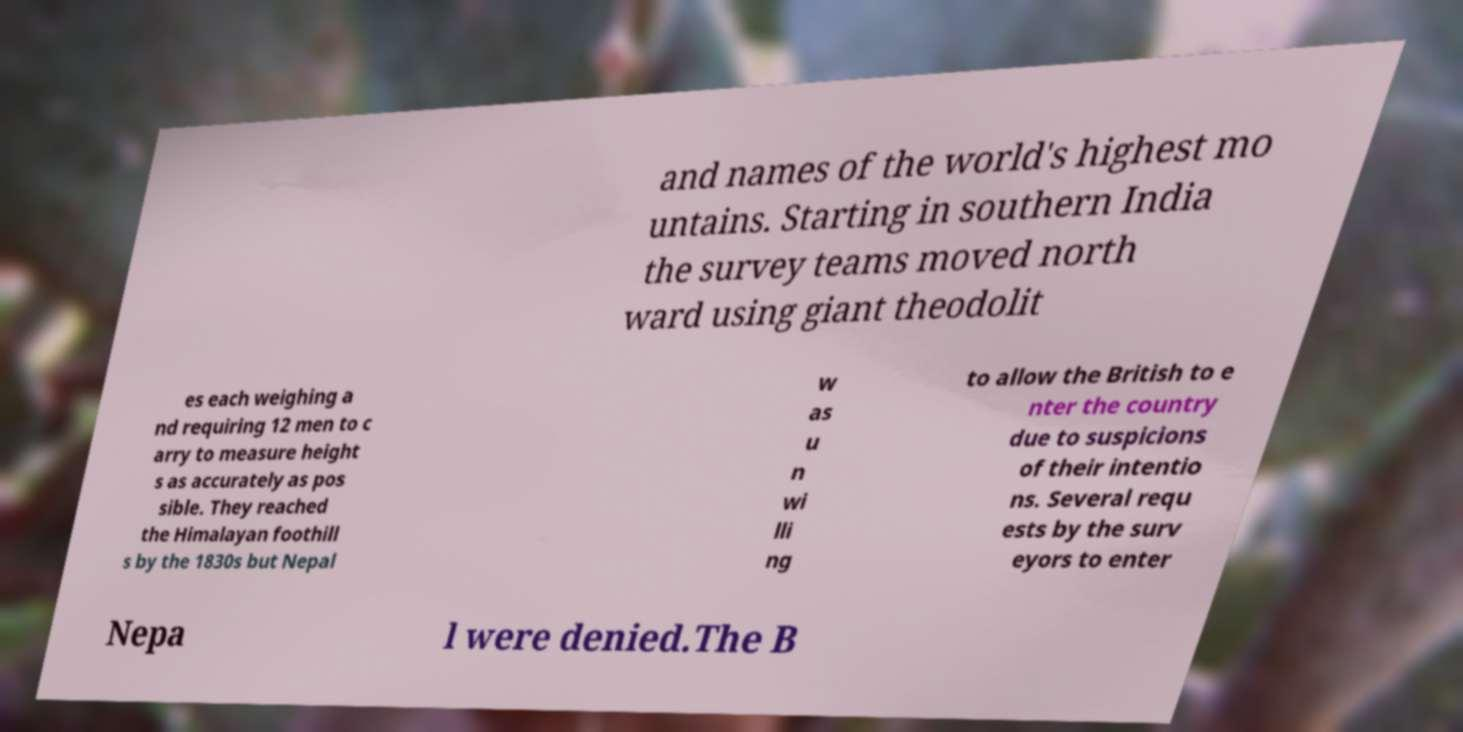Please read and relay the text visible in this image. What does it say? and names of the world's highest mo untains. Starting in southern India the survey teams moved north ward using giant theodolit es each weighing a nd requiring 12 men to c arry to measure height s as accurately as pos sible. They reached the Himalayan foothill s by the 1830s but Nepal w as u n wi lli ng to allow the British to e nter the country due to suspicions of their intentio ns. Several requ ests by the surv eyors to enter Nepa l were denied.The B 